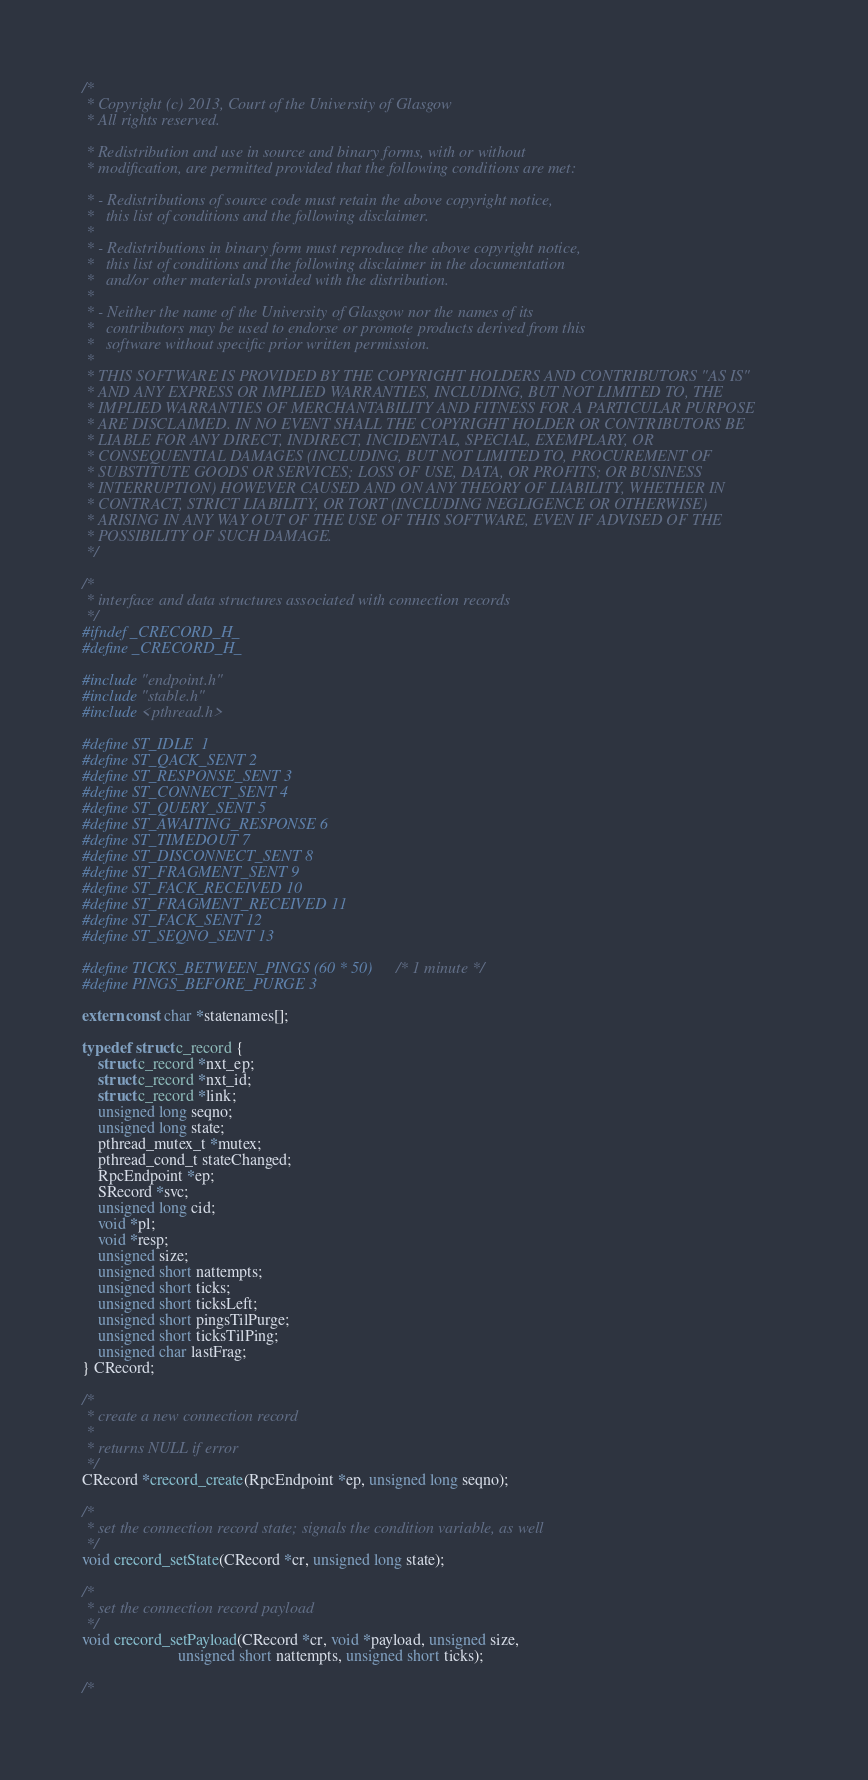<code> <loc_0><loc_0><loc_500><loc_500><_C_>/*
 * Copyright (c) 2013, Court of the University of Glasgow
 * All rights reserved.

 * Redistribution and use in source and binary forms, with or without
 * modification, are permitted provided that the following conditions are met:

 * - Redistributions of source code must retain the above copyright notice,
 *   this list of conditions and the following disclaimer.
 *
 * - Redistributions in binary form must reproduce the above copyright notice,
 *   this list of conditions and the following disclaimer in the documentation
 *   and/or other materials provided with the distribution.
 *
 * - Neither the name of the University of Glasgow nor the names of its
 *   contributors may be used to endorse or promote products derived from this
 *   software without specific prior written permission.
 *
 * THIS SOFTWARE IS PROVIDED BY THE COPYRIGHT HOLDERS AND CONTRIBUTORS "AS IS"
 * AND ANY EXPRESS OR IMPLIED WARRANTIES, INCLUDING, BUT NOT LIMITED TO, THE
 * IMPLIED WARRANTIES OF MERCHANTABILITY AND FITNESS FOR A PARTICULAR PURPOSE
 * ARE DISCLAIMED. IN NO EVENT SHALL THE COPYRIGHT HOLDER OR CONTRIBUTORS BE
 * LIABLE FOR ANY DIRECT, INDIRECT, INCIDENTAL, SPECIAL, EXEMPLARY, OR
 * CONSEQUENTIAL DAMAGES (INCLUDING, BUT NOT LIMITED TO, PROCUREMENT OF
 * SUBSTITUTE GOODS OR SERVICES; LOSS OF USE, DATA, OR PROFITS; OR BUSINESS
 * INTERRUPTION) HOWEVER CAUSED AND ON ANY THEORY OF LIABILITY, WHETHER IN
 * CONTRACT, STRICT LIABILITY, OR TORT (INCLUDING NEGLIGENCE OR OTHERWISE)
 * ARISING IN ANY WAY OUT OF THE USE OF THIS SOFTWARE, EVEN IF ADVISED OF THE
 * POSSIBILITY OF SUCH DAMAGE.
 */

/*
 * interface and data structures associated with connection records
 */
#ifndef _CRECORD_H_
#define _CRECORD_H_

#include "endpoint.h"
#include "stable.h"
#include <pthread.h>

#define ST_IDLE	1
#define ST_QACK_SENT 2
#define ST_RESPONSE_SENT 3
#define ST_CONNECT_SENT 4
#define ST_QUERY_SENT 5
#define ST_AWAITING_RESPONSE 6
#define ST_TIMEDOUT 7
#define ST_DISCONNECT_SENT 8
#define ST_FRAGMENT_SENT 9
#define ST_FACK_RECEIVED 10
#define ST_FRAGMENT_RECEIVED 11
#define ST_FACK_SENT 12
#define ST_SEQNO_SENT 13

#define TICKS_BETWEEN_PINGS (60 * 50)	/* 1 minute */
#define PINGS_BEFORE_PURGE 3

extern const char *statenames[];

typedef struct c_record {
    struct c_record *nxt_ep;
    struct c_record *nxt_id;
    struct c_record *link;
    unsigned long seqno;
    unsigned long state;
    pthread_mutex_t *mutex;
    pthread_cond_t stateChanged;
    RpcEndpoint *ep;
    SRecord *svc;
    unsigned long cid;
    void *pl;
    void *resp;
    unsigned size;
    unsigned short nattempts;
    unsigned short ticks;
    unsigned short ticksLeft;
    unsigned short pingsTilPurge;
    unsigned short ticksTilPing;
    unsigned char lastFrag;
} CRecord;

/*
 * create a new connection record
 *
 * returns NULL if error
 */
CRecord *crecord_create(RpcEndpoint *ep, unsigned long seqno);

/*
 * set the connection record state; signals the condition variable, as well
 */
void crecord_setState(CRecord *cr, unsigned long state);

/*
 * set the connection record payload
 */
void crecord_setPayload(CRecord *cr, void *payload, unsigned size,
                        unsigned short nattempts, unsigned short ticks);

/*</code> 